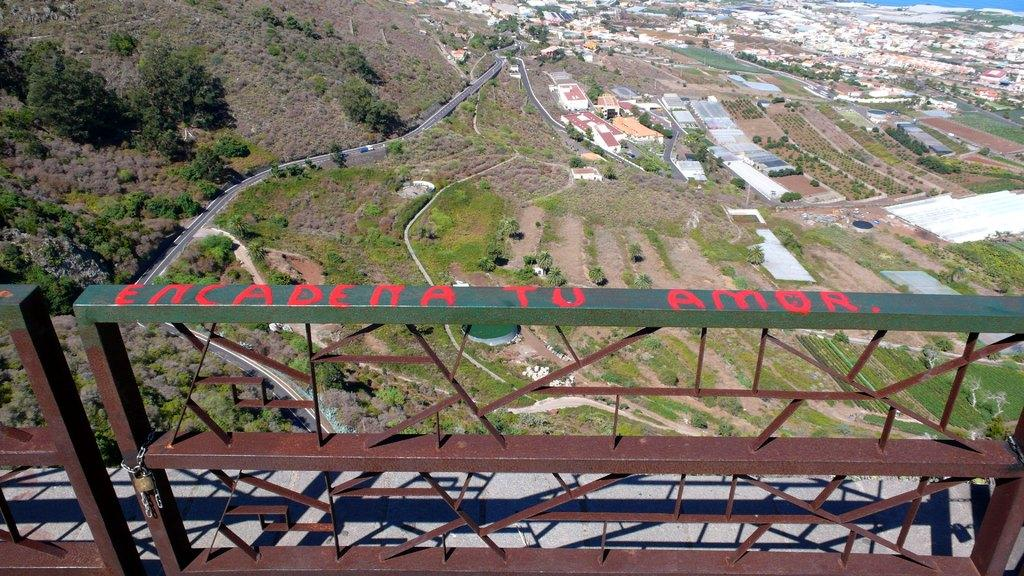What type of structure can be seen in the image? There are iron railings in the image. What can be found on the ground in the image? There are many trees on the ground in the image. What else is visible in the image besides trees and railings? There are buildings and a road in the image. How would you describe the overall appearance of the image? The background of the image is slightly blurred. What type of bell can be seen hanging from the edge of the page in the image? There is no bell or page present in the image, so it is not possible to answer that question. 